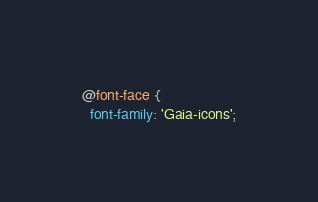Convert code to text. <code><loc_0><loc_0><loc_500><loc_500><_CSS_>@font-face {
  font-family: 'Gaia-icons';</code> 